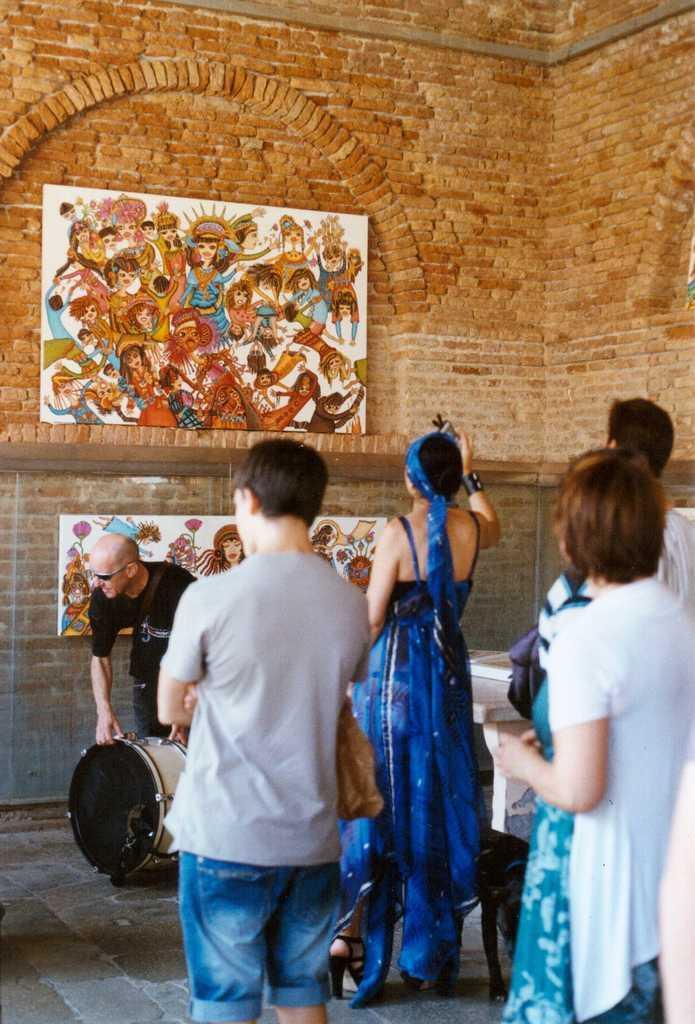Please provide a concise description of this image. In this image there are group of persons standing and at the top of the image there is a painting attached to the red color brick color wall. 